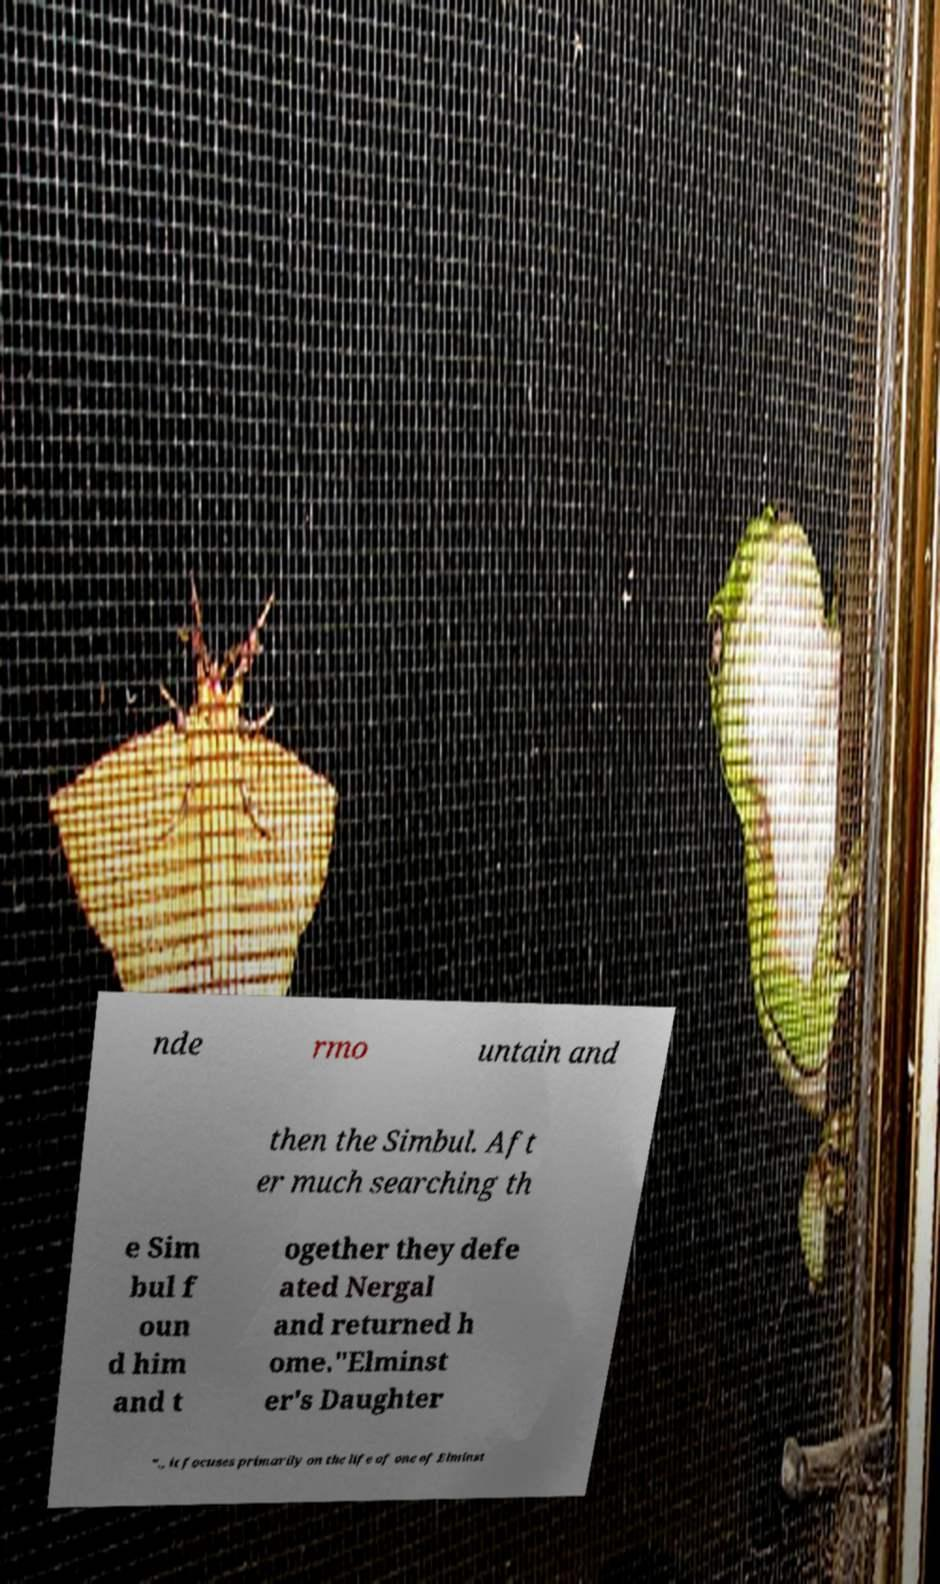Please read and relay the text visible in this image. What does it say? nde rmo untain and then the Simbul. Aft er much searching th e Sim bul f oun d him and t ogether they defe ated Nergal and returned h ome."Elminst er's Daughter "., it focuses primarily on the life of one of Elminst 